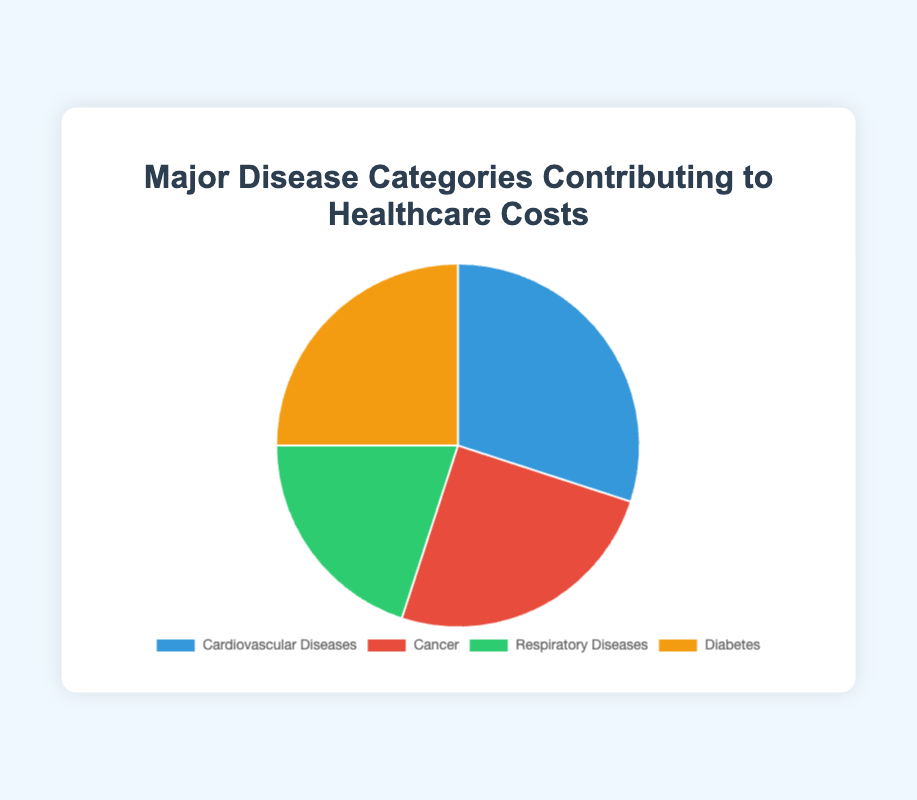question explanation
Answer: concise answer What percentage of healthcare costs is attributed to Diabetes and Cancer combined? Diabetes accounts for 25% and Cancer accounts for 25% of healthcare costs. Adding these percentages yields 25% + 25% = 50%.
Answer: 50% Which disease category contributes the most to healthcare costs? The pie chart shows four categories with their respective percentages: Cardiovascular Diseases (30%), Cancer (25%), Respiratory Diseases (20%), and Diabetes (25%). The highest percentage is for Cardiovascular Diseases at 30%.
Answer: Cardiovascular Diseases What is the difference in percentage contribution to healthcare costs between Cardiovascular Diseases and Respiratory Diseases? Cardiovascular Diseases contribute 30% and Respiratory Diseases contribute 20%. The difference is 30% - 20% = 10%.
Answer: 10% Which two disease categories contribute equally to healthcare costs? According to the pie chart, both Cancer and Diabetes contribute 25% each to healthcare costs.
Answer: Cancer and Diabetes What is the sum of the contributions of the Respiratory Diseases and Diabetes categories? Respiratory Diseases contribute 20%, and Diabetes contributes 25% to healthcare costs. Adding them together results in 20% + 25% = 45%.
Answer: 45% What is the average percentage contribution to healthcare costs by all the disease categories? The percentages of the four categories are 30%, 25%, 20%, and 25%. Adding them yields 30 + 25 + 20 + 25 = 100. Dividing this sum by 4 gives the average, which is 100 / 4 = 25%.
Answer: 25% Are there more disease categories that contribute 25% each, or fewer? There are two categories (Cancer and Diabetes) that each contribute 25%. Since there are four categories in total, there are an equal number of categories contributing 25% and not contributing 25%.
Answer: Equal What color represents the category that contributes the least to healthcare costs? Respiratory Diseases contribute the least at 20%, and their associated color on the pie chart is green.
Answer: Green 